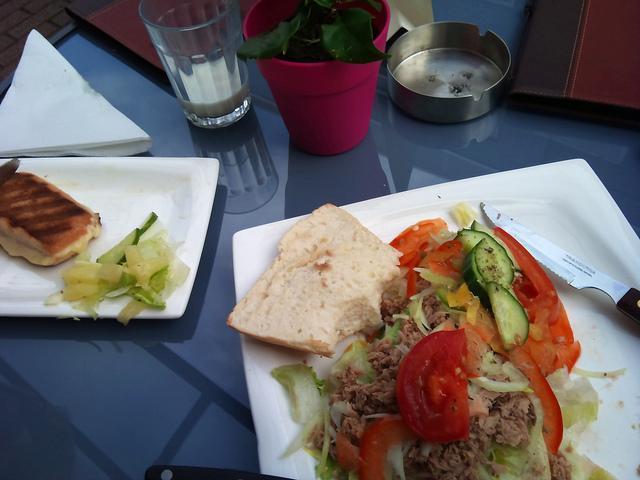What do the stains on the middle top metal thing come from?
Make your selection from the four choices given to correctly answer the question.
Options: Blood, juice, oil, cigarettes. Cigarettes. 